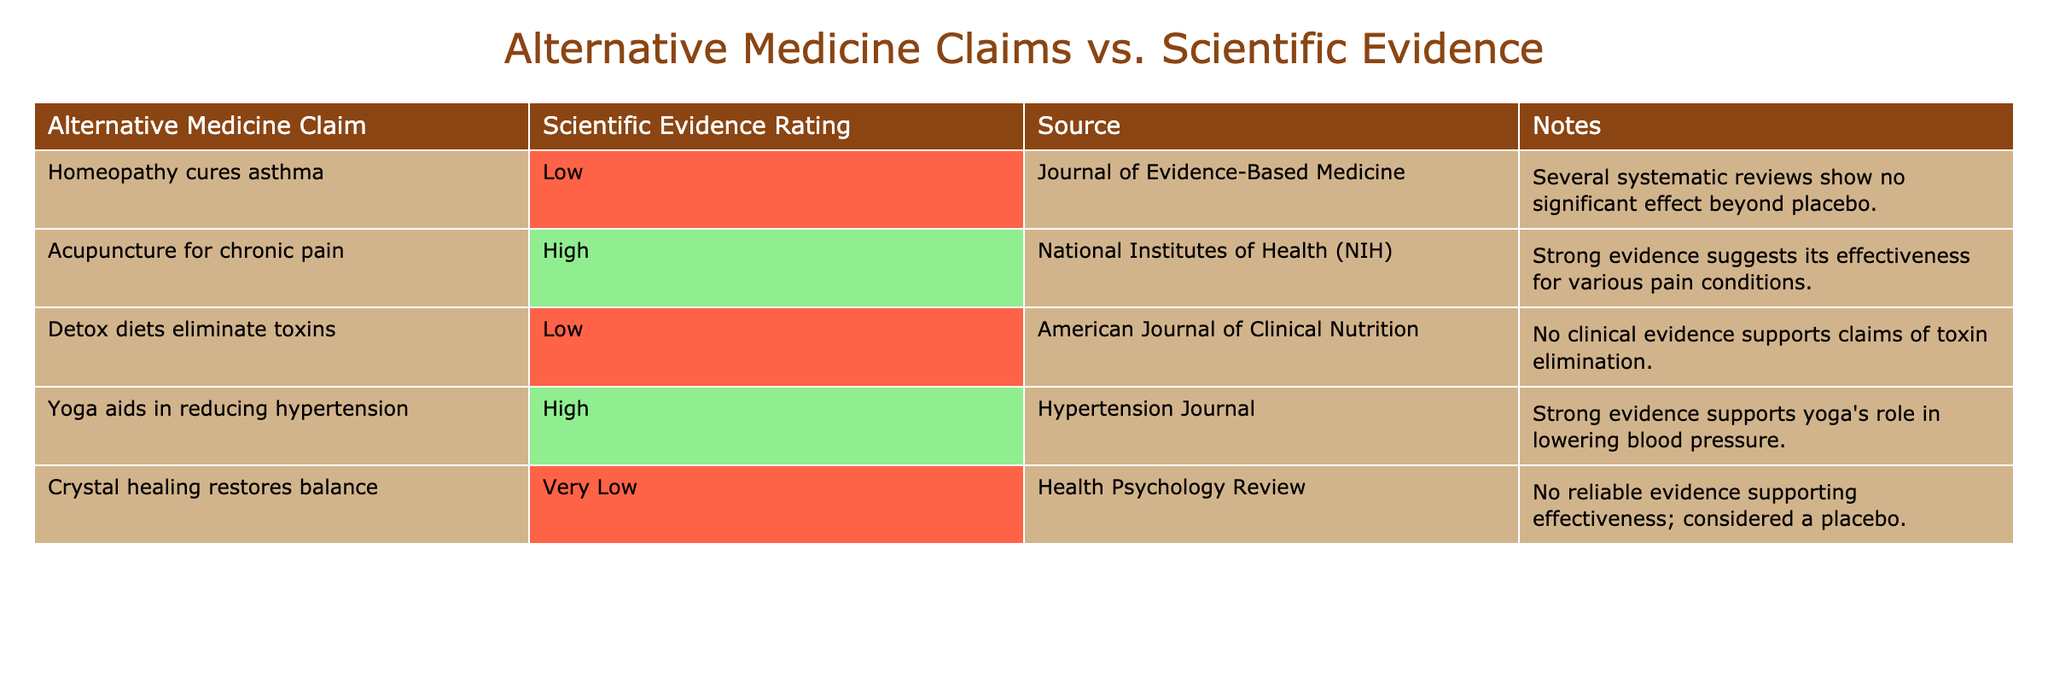What is the scientific evidence rating for "Yoga aids in reducing hypertension"? The table shows that the scientific evidence rating for "Yoga aids in reducing hypertension" is "High".
Answer: High Which claim has the lowest scientific evidence rating? The claim "Crystal healing restores balance" has the lowest scientific evidence rating, which is "Very Low".
Answer: Crystal healing restores balance How many claims have a high scientific evidence rating? There are two claims with a high scientific evidence rating: "Acupuncture for chronic pain" and "Yoga aids in reducing hypertension".
Answer: 2 Is there any alternative medicine claim that has a rating of "Very Low"? Yes, the claim "Crystal healing restores balance" has a rating of "Very Low".
Answer: Yes What is the source for the claim "Detox diets eliminate toxins"? The source for the claim "Detox diets eliminate toxins" is the "American Journal of Clinical Nutrition".
Answer: American Journal of Clinical Nutrition List the claims that have low or very low evidence ratings. The claims with low or very low evidence ratings are "Homeopathy cures asthma", "Detox diets eliminate toxins", and "Crystal healing restores balance".
Answer: Homeopathy cures asthma, Detox diets eliminate toxins, Crystal healing restores balance What is the difference in scientific evidence ratings between "Acupuncture for chronic pain" and "Homeopathy cures asthma"? "Acupuncture for chronic pain" has a high rating, while "Homeopathy cures asthma" has a low rating. The difference is from high to low.
Answer: High to Low If two alternative medicine claims are selected randomly, what is the probability that they both have a high scientific evidence rating? There are 2 claims rated high out of 5 total claims, so the probability is (2/5) * (1/4) = 1/10.
Answer: 1/10 Which claim has the strongest scientific evidence according to the table? The claim with the strongest scientific evidence according to the table is "Acupuncture for chronic pain", which has a "High" rating.
Answer: Acupuncture for chronic pain How does the scientific evidence for "Homeopathy cures asthma" compare to "Detox diets eliminate toxins"? Both claims have low scientific evidence ratings, but "Homeopathy cures asthma" is rated as low and "Detox diets eliminate toxins" is also rated low, showing no significant difference between them.
Answer: They are both low What do the notes for "Crystal healing restores balance" indicate about its effectiveness? The notes state that there is no reliable evidence supporting the effectiveness of "Crystal healing", and it is considered a placebo.
Answer: No reliable evidence; considered a placebo 